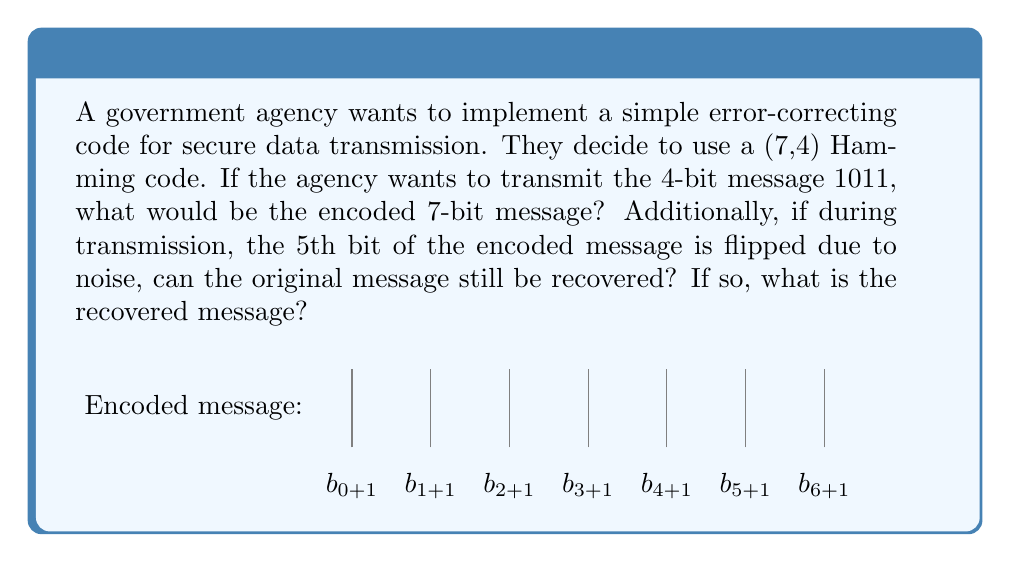Can you answer this question? Let's approach this step-by-step:

1) In a (7,4) Hamming code, we have 4 data bits and 3 parity bits. The parity bits are placed at positions that are powers of 2 (positions 1, 2, and 4 in a 1-indexed system).

2) Let's denote our data bits as $d_1, d_2, d_3, d_4$ and our parity bits as $p_1, p_2, p_3$. The encoded message will be in the form:

   $p_1, p_2, d_1, p_3, d_2, d_3, d_4$

3) For the message 1011:
   $d_1 = 1, d_2 = 0, d_3 = 1, d_4 = 1$

4) To calculate the parity bits:
   $p_1 = d_1 \oplus d_2 \oplus d_4 = 1 \oplus 0 \oplus 1 = 0$
   $p_2 = d_1 \oplus d_3 \oplus d_4 = 1 \oplus 1 \oplus 1 = 1$
   $p_3 = d_2 \oplus d_3 \oplus d_4 = 0 \oplus 1 \oplus 1 = 0$

5) Therefore, the encoded message is: 0110011

6) If the 5th bit is flipped, the received message becomes: 0110111

7) To detect and correct the error:
   Check 1: $p_1 \oplus d_1 \oplus d_2 \oplus d_4 = 0 \oplus 1 \oplus 1 \oplus 1 = 1$
   Check 2: $p_2 \oplus d_1 \oplus d_3 \oplus d_4 = 1 \oplus 1 \oplus 1 \oplus 1 = 0$
   Check 3: $p_3 \oplus d_2 \oplus d_3 \oplus d_4 = 0 \oplus 1 \oplus 1 \oplus 1 = 1$

8) The error syndrome is 101 in binary, which corresponds to position 5.

9) Flipping the 5th bit back, we get the correct encoded message: 0110011

10) Extracting the data bits (3rd, 5th, 6th, and 7th positions), we recover the original message: 1011

Thus, the original message can be recovered despite the error.
Answer: Encoded: 0110011; Recovered: 1011 